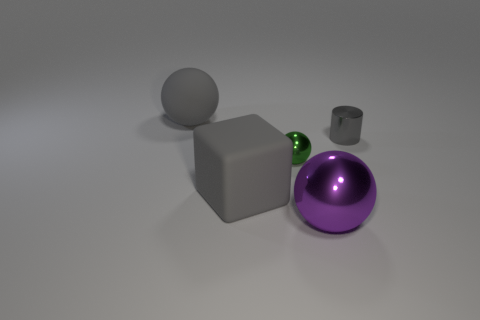What size is the rubber thing that is the same color as the rubber cube?
Your answer should be compact. Large. What is the shape of the big gray thing that is in front of the big gray thing behind the large gray block?
Give a very brief answer. Cube. Does the gray object to the right of the purple shiny thing have the same shape as the green metal object?
Your response must be concise. No. There is a object that is made of the same material as the big gray ball; what is its size?
Make the answer very short. Large. How many things are tiny metallic objects that are on the left side of the purple sphere or large balls that are to the left of the purple shiny object?
Offer a very short reply. 2. Is the number of rubber balls right of the gray metallic thing the same as the number of tiny gray cylinders in front of the tiny green metallic object?
Provide a short and direct response. Yes. What color is the large sphere that is behind the purple object?
Offer a very short reply. Gray. There is a small ball; does it have the same color as the matte object behind the gray metallic thing?
Offer a terse response. No. Is the number of big gray cylinders less than the number of small gray things?
Offer a very short reply. Yes. There is a matte object that is behind the gray cylinder; does it have the same color as the tiny metal cylinder?
Keep it short and to the point. Yes. 